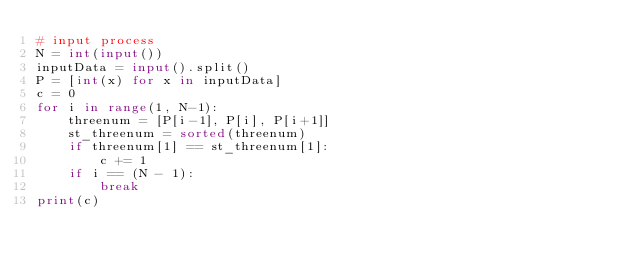<code> <loc_0><loc_0><loc_500><loc_500><_Python_># input process
N = int(input())
inputData = input().split()
P = [int(x) for x in inputData]
c = 0
for i in range(1, N-1):
    threenum = [P[i-1], P[i], P[i+1]]
    st_threenum = sorted(threenum)
    if threenum[1] == st_threenum[1]:
        c += 1
    if i == (N - 1):
        break
print(c)
</code> 